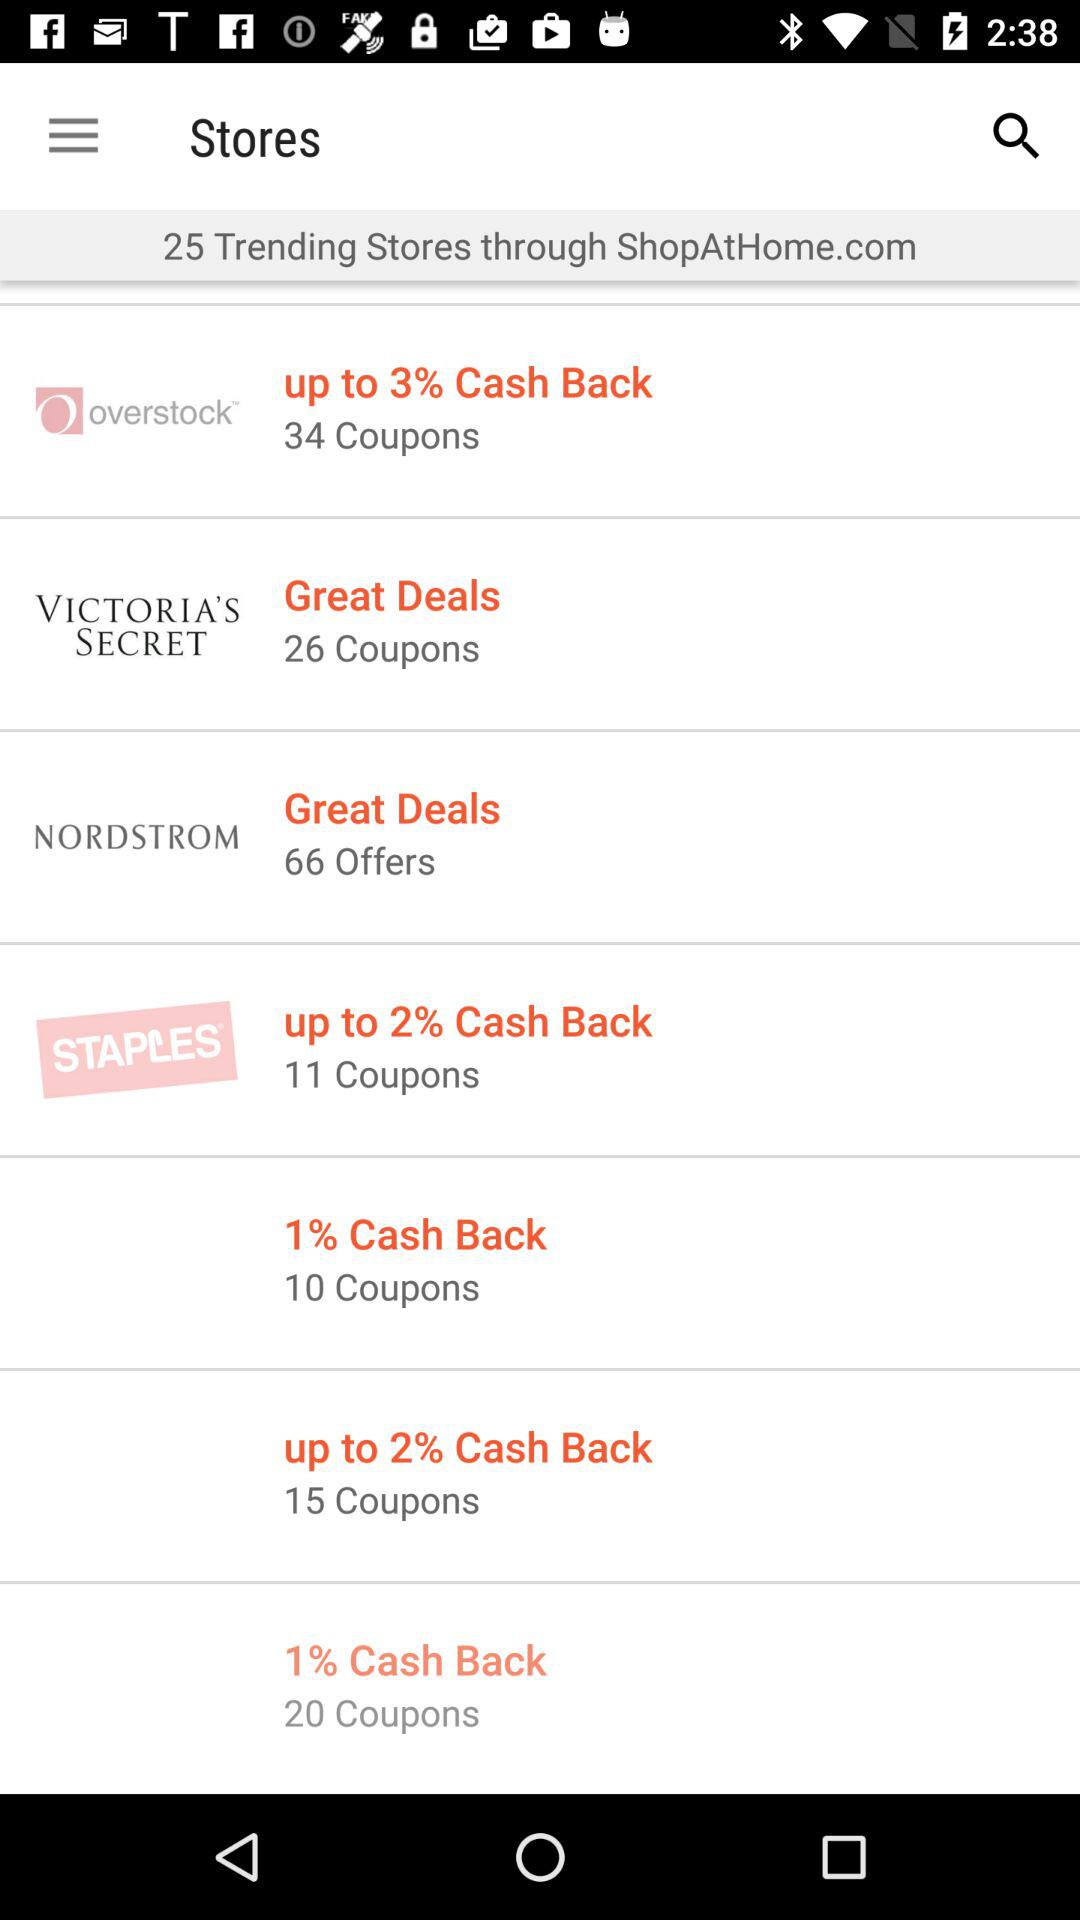How many coupons are there for "VICTORIA'S SECRET"? There are 26 coupons. 